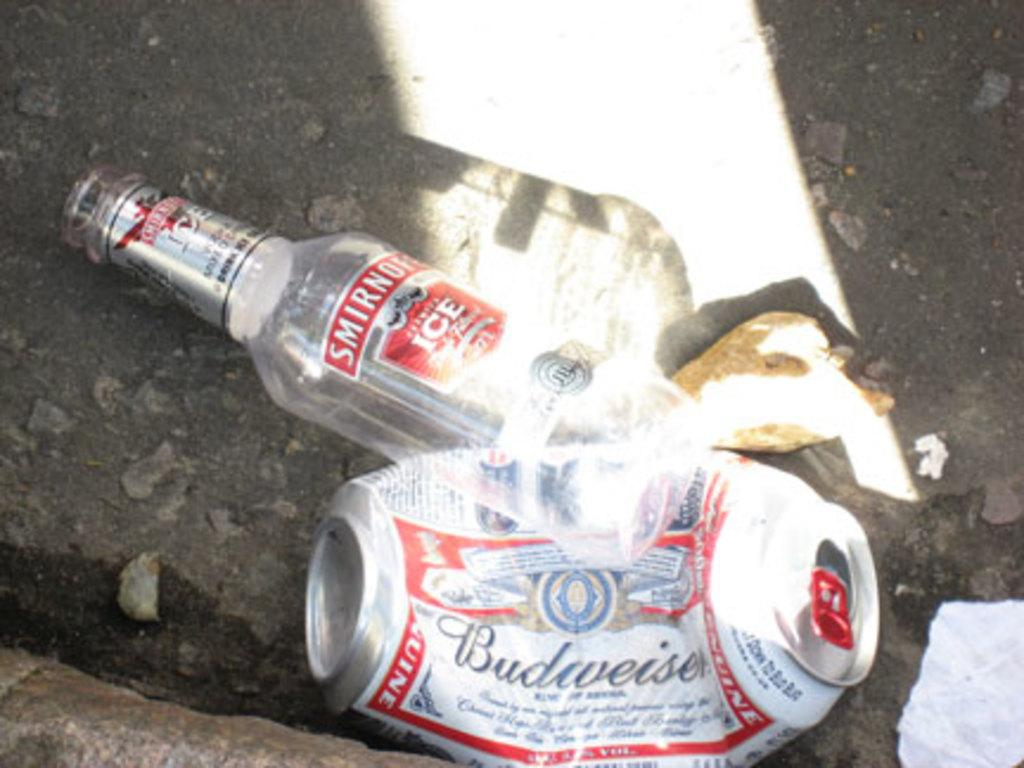<image>
Summarize the visual content of the image. Crushed Budweiser can next to an empty Smirnoff bottle. 